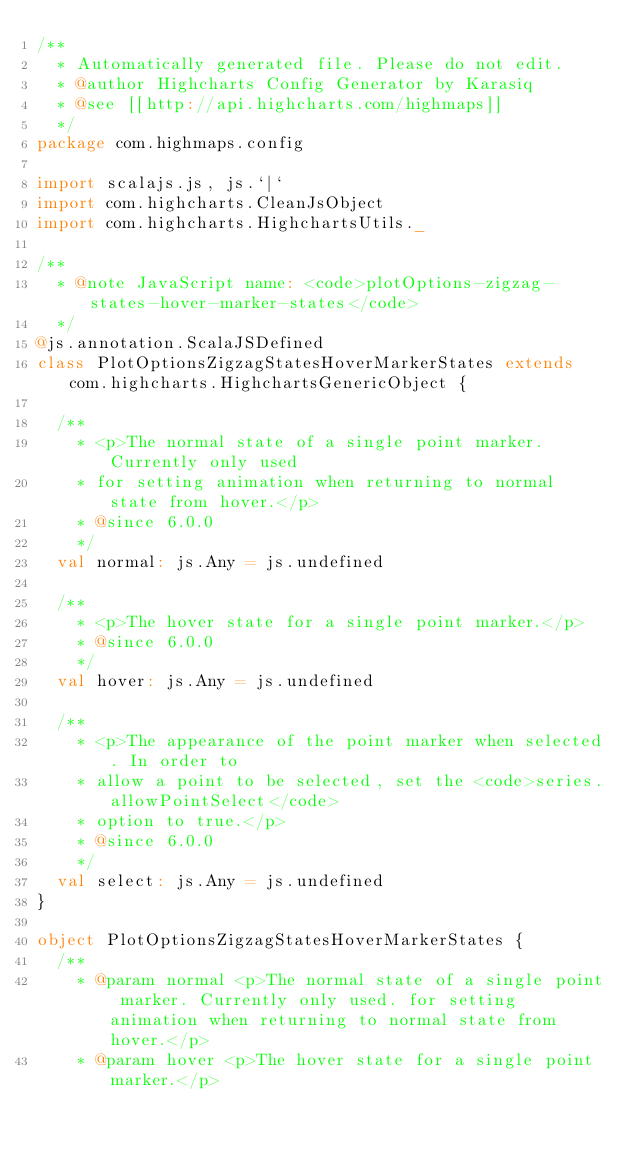Convert code to text. <code><loc_0><loc_0><loc_500><loc_500><_Scala_>/**
  * Automatically generated file. Please do not edit.
  * @author Highcharts Config Generator by Karasiq
  * @see [[http://api.highcharts.com/highmaps]]
  */
package com.highmaps.config

import scalajs.js, js.`|`
import com.highcharts.CleanJsObject
import com.highcharts.HighchartsUtils._

/**
  * @note JavaScript name: <code>plotOptions-zigzag-states-hover-marker-states</code>
  */
@js.annotation.ScalaJSDefined
class PlotOptionsZigzagStatesHoverMarkerStates extends com.highcharts.HighchartsGenericObject {

  /**
    * <p>The normal state of a single point marker. Currently only used
    * for setting animation when returning to normal state from hover.</p>
    * @since 6.0.0
    */
  val normal: js.Any = js.undefined

  /**
    * <p>The hover state for a single point marker.</p>
    * @since 6.0.0
    */
  val hover: js.Any = js.undefined

  /**
    * <p>The appearance of the point marker when selected. In order to
    * allow a point to be selected, set the <code>series.allowPointSelect</code>
    * option to true.</p>
    * @since 6.0.0
    */
  val select: js.Any = js.undefined
}

object PlotOptionsZigzagStatesHoverMarkerStates {
  /**
    * @param normal <p>The normal state of a single point marker. Currently only used. for setting animation when returning to normal state from hover.</p>
    * @param hover <p>The hover state for a single point marker.</p></code> 